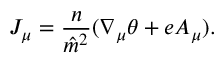<formula> <loc_0><loc_0><loc_500><loc_500>J _ { \mu } = \frac { n } { \hat { m } ^ { 2 } } ( \nabla _ { \mu } \theta + e A _ { \mu } ) .</formula> 